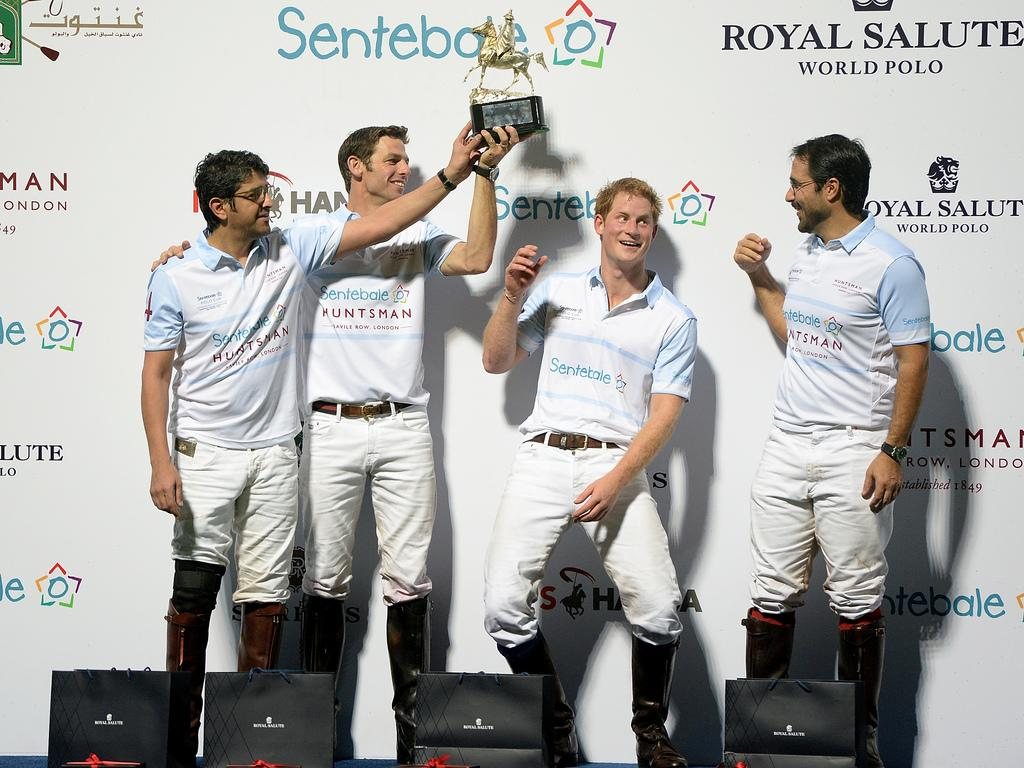Provide a one-sentence caption for the provided image. Four men stand with a trophy in front of a wall that says Royal Salute World Polo. 